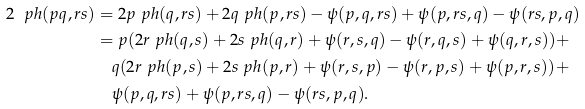<formula> <loc_0><loc_0><loc_500><loc_500>2 \ p h ( p q , r s ) & = 2 p \ p h ( q , r s ) + 2 q \ p h ( p , r s ) - \psi ( p , q , r s ) + \psi ( p , r s , q ) - \psi ( r s , p , q ) \\ & = p ( 2 r \ p h ( q , s ) + 2 s \ p h ( q , r ) + \psi ( r , s , q ) - \psi ( r , q , s ) + \psi ( q , r , s ) ) + \\ & \quad q ( 2 r \ p h ( p , s ) + 2 s \ p h ( p , r ) + \psi ( r , s , p ) - \psi ( r , p , s ) + \psi ( p , r , s ) ) + \\ & \quad \psi ( p , q , r s ) + \psi ( p , r s , q ) - \psi ( r s , p , q ) .</formula> 